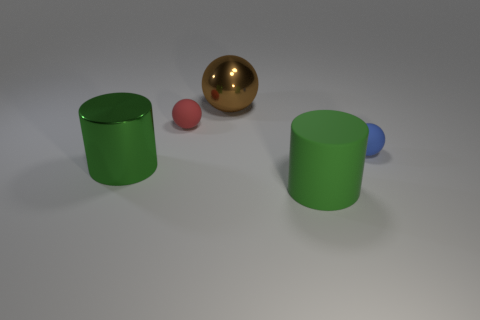There is a thing that is in front of the blue sphere and behind the big matte thing; what size is it?
Make the answer very short. Large. Does the green metallic cylinder have the same size as the brown ball?
Make the answer very short. Yes. Do the metallic thing that is to the left of the red ball and the large rubber thing have the same color?
Make the answer very short. Yes. How many big cylinders are behind the green metal cylinder?
Offer a very short reply. 0. Are there more large purple metal cubes than rubber cylinders?
Your answer should be compact. No. There is a rubber thing that is to the right of the brown metal sphere and on the left side of the blue matte sphere; what is its shape?
Provide a succinct answer. Cylinder. Is there a yellow ball?
Your answer should be compact. No. There is a blue object that is the same shape as the red rubber object; what is its material?
Keep it short and to the point. Rubber. There is a small thing that is on the right side of the big green object that is to the right of the small matte thing that is on the left side of the green rubber cylinder; what is its shape?
Keep it short and to the point. Sphere. There is another cylinder that is the same color as the big metallic cylinder; what is its material?
Keep it short and to the point. Rubber. 